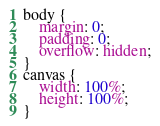Convert code to text. <code><loc_0><loc_0><loc_500><loc_500><_CSS_>body {
	margin: 0;
	padding: 0;
	overflow: hidden;
}
canvas {
	width: 100%;
	height: 100%;
}
</code> 